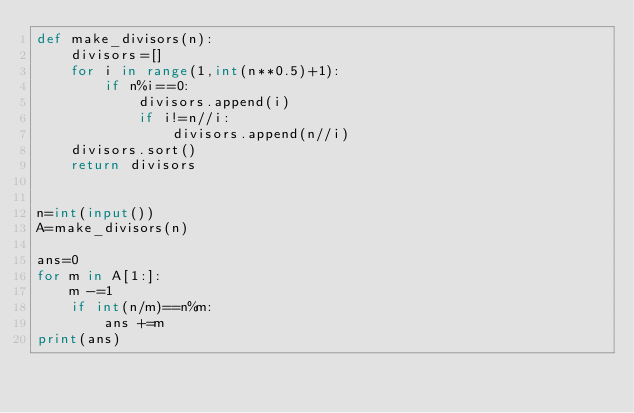<code> <loc_0><loc_0><loc_500><loc_500><_Python_>def make_divisors(n):
    divisors=[]
    for i in range(1,int(n**0.5)+1):
        if n%i==0:
            divisors.append(i)
            if i!=n//i:
                divisors.append(n//i)
    divisors.sort()
    return divisors


n=int(input())
A=make_divisors(n)

ans=0
for m in A[1:]:
    m -=1
    if int(n/m)==n%m:
        ans +=m
print(ans)
</code> 